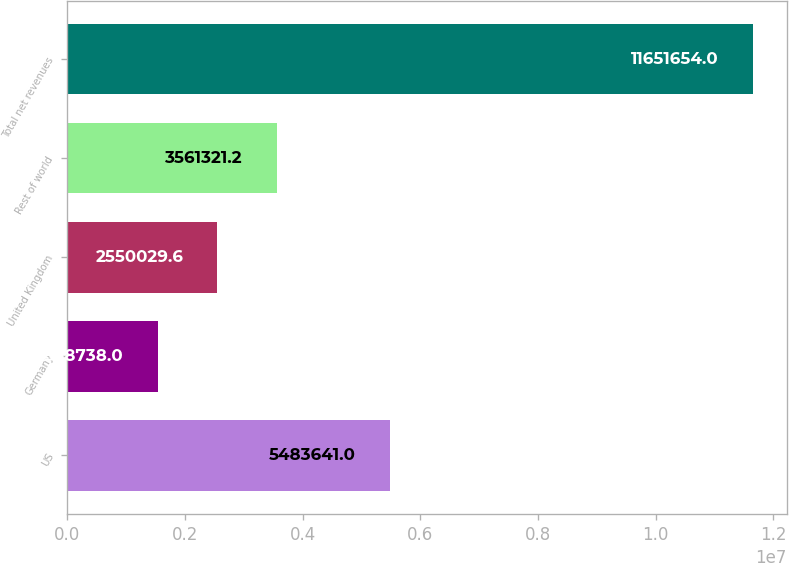<chart> <loc_0><loc_0><loc_500><loc_500><bar_chart><fcel>US<fcel>Germany<fcel>United Kingdom<fcel>Rest of world<fcel>Total net revenues<nl><fcel>5.48364e+06<fcel>1.53874e+06<fcel>2.55003e+06<fcel>3.56132e+06<fcel>1.16517e+07<nl></chart> 